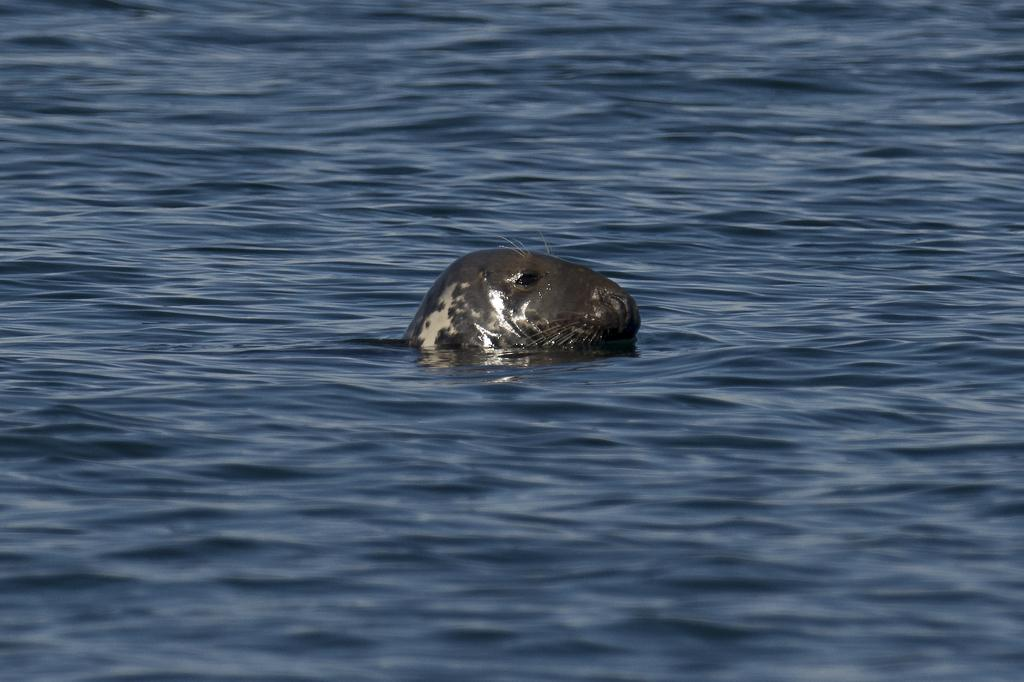What type of animal is in the image? The animal in the image is not specified, but it has grey and cream coloring. Can you describe the coloring of the animal? The animal has grey and cream coloring. What is the environment in which the animal is situated? The animal is in blue color water. What type of print is visible on the animal in the image? There is no print visible on the animal in the image. 